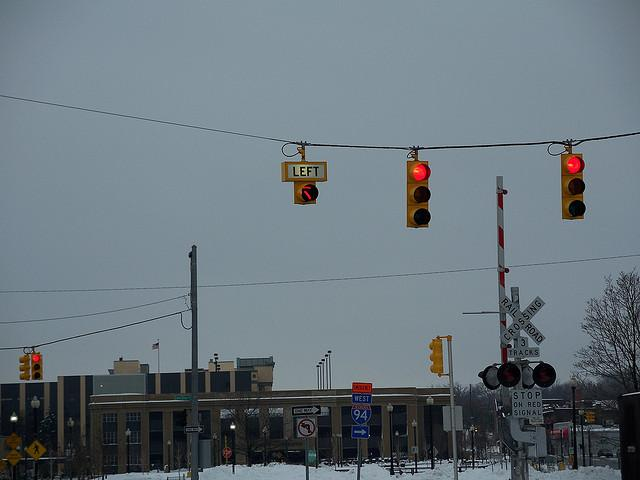What vehicle makes frequent crosses at this intersection? train 